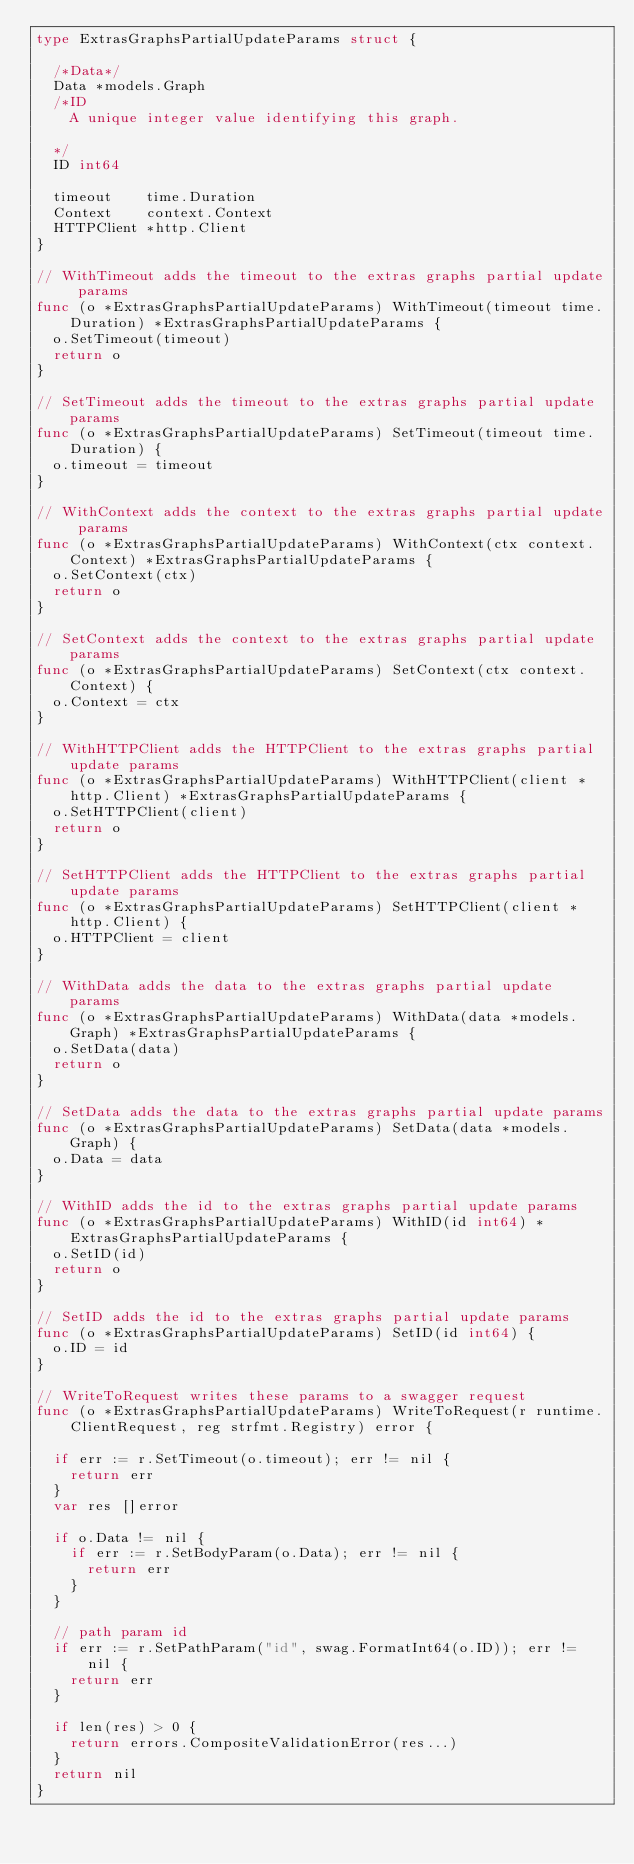Convert code to text. <code><loc_0><loc_0><loc_500><loc_500><_Go_>type ExtrasGraphsPartialUpdateParams struct {

	/*Data*/
	Data *models.Graph
	/*ID
	  A unique integer value identifying this graph.

	*/
	ID int64

	timeout    time.Duration
	Context    context.Context
	HTTPClient *http.Client
}

// WithTimeout adds the timeout to the extras graphs partial update params
func (o *ExtrasGraphsPartialUpdateParams) WithTimeout(timeout time.Duration) *ExtrasGraphsPartialUpdateParams {
	o.SetTimeout(timeout)
	return o
}

// SetTimeout adds the timeout to the extras graphs partial update params
func (o *ExtrasGraphsPartialUpdateParams) SetTimeout(timeout time.Duration) {
	o.timeout = timeout
}

// WithContext adds the context to the extras graphs partial update params
func (o *ExtrasGraphsPartialUpdateParams) WithContext(ctx context.Context) *ExtrasGraphsPartialUpdateParams {
	o.SetContext(ctx)
	return o
}

// SetContext adds the context to the extras graphs partial update params
func (o *ExtrasGraphsPartialUpdateParams) SetContext(ctx context.Context) {
	o.Context = ctx
}

// WithHTTPClient adds the HTTPClient to the extras graphs partial update params
func (o *ExtrasGraphsPartialUpdateParams) WithHTTPClient(client *http.Client) *ExtrasGraphsPartialUpdateParams {
	o.SetHTTPClient(client)
	return o
}

// SetHTTPClient adds the HTTPClient to the extras graphs partial update params
func (o *ExtrasGraphsPartialUpdateParams) SetHTTPClient(client *http.Client) {
	o.HTTPClient = client
}

// WithData adds the data to the extras graphs partial update params
func (o *ExtrasGraphsPartialUpdateParams) WithData(data *models.Graph) *ExtrasGraphsPartialUpdateParams {
	o.SetData(data)
	return o
}

// SetData adds the data to the extras graphs partial update params
func (o *ExtrasGraphsPartialUpdateParams) SetData(data *models.Graph) {
	o.Data = data
}

// WithID adds the id to the extras graphs partial update params
func (o *ExtrasGraphsPartialUpdateParams) WithID(id int64) *ExtrasGraphsPartialUpdateParams {
	o.SetID(id)
	return o
}

// SetID adds the id to the extras graphs partial update params
func (o *ExtrasGraphsPartialUpdateParams) SetID(id int64) {
	o.ID = id
}

// WriteToRequest writes these params to a swagger request
func (o *ExtrasGraphsPartialUpdateParams) WriteToRequest(r runtime.ClientRequest, reg strfmt.Registry) error {

	if err := r.SetTimeout(o.timeout); err != nil {
		return err
	}
	var res []error

	if o.Data != nil {
		if err := r.SetBodyParam(o.Data); err != nil {
			return err
		}
	}

	// path param id
	if err := r.SetPathParam("id", swag.FormatInt64(o.ID)); err != nil {
		return err
	}

	if len(res) > 0 {
		return errors.CompositeValidationError(res...)
	}
	return nil
}
</code> 